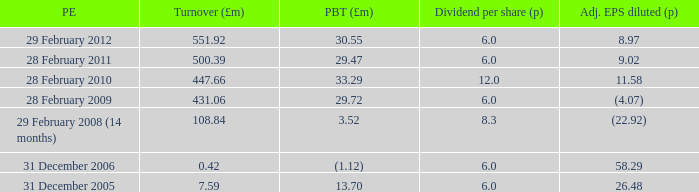What was the turnover when the profit before tax was 29.47? 500.39. 